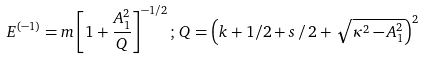Convert formula to latex. <formula><loc_0><loc_0><loc_500><loc_500>E ^ { \left ( - 1 \right ) } = m \left [ 1 + \frac { A _ { 1 } ^ { 2 } } { Q } \right ] ^ { - 1 / 2 } ; \, Q = \left ( k + 1 / 2 + s \, / \, 2 + \, \sqrt { \kappa ^ { 2 } - A _ { 1 } ^ { 2 } } \right ) ^ { 2 }</formula> 